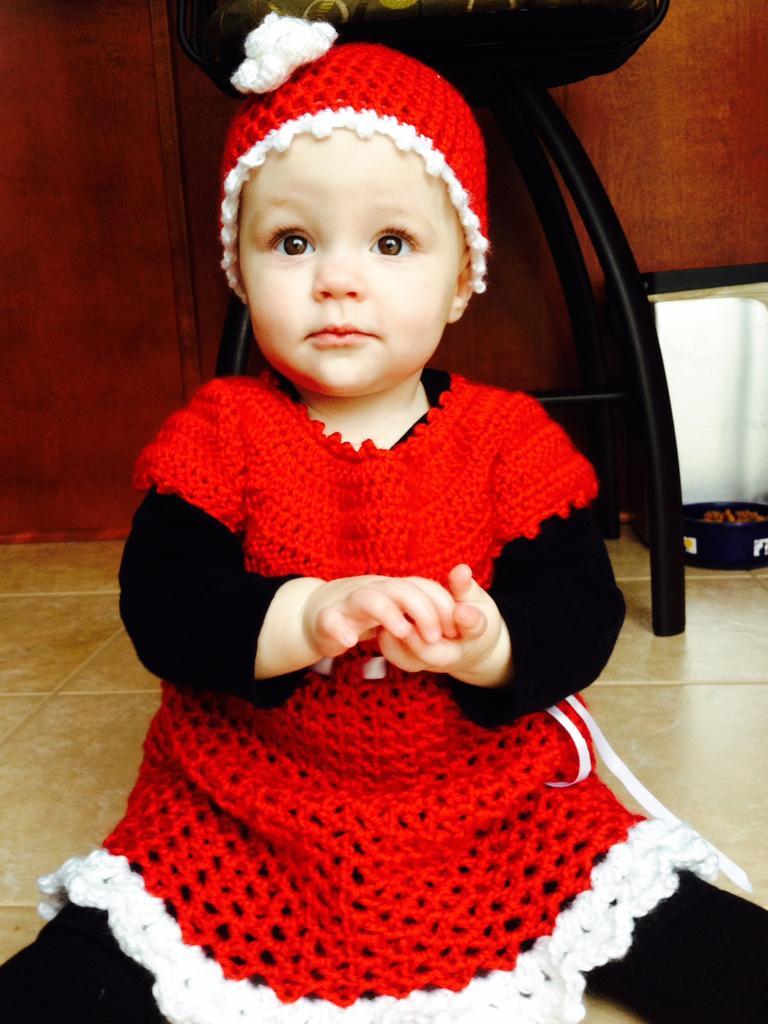Describe this image in one or two sentences. In this picture there is a girl sitting on the floor. In the background of the image we can see chair, objects and wall. 